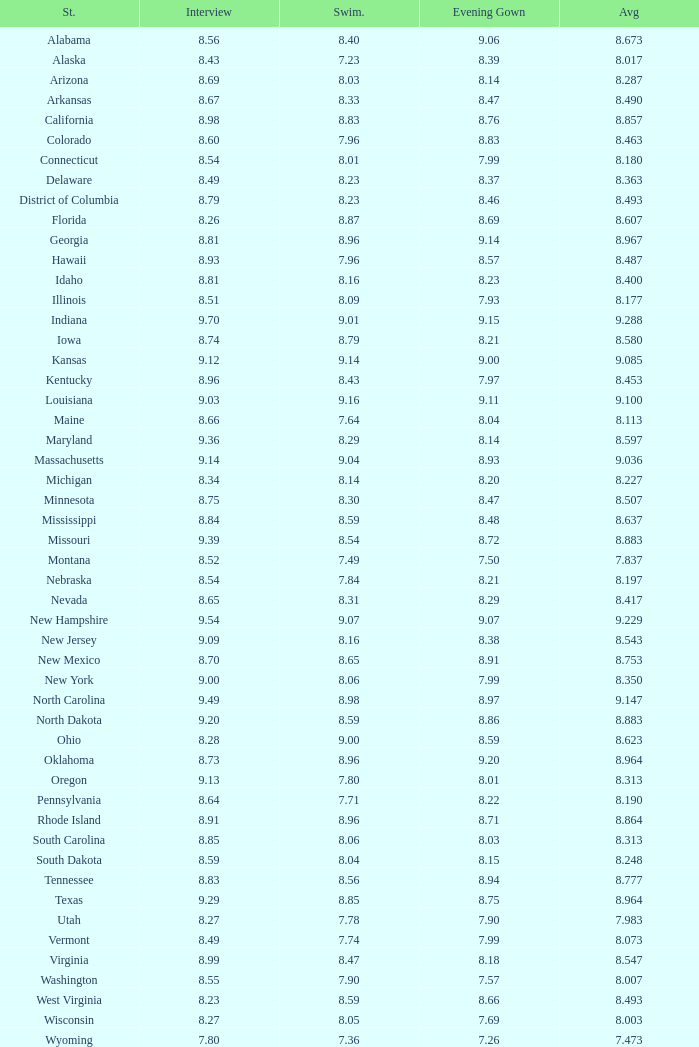Tell me the sum of interview for evening gown more than 8.37 and average of 8.363 None. Write the full table. {'header': ['St.', 'Interview', 'Swim.', 'Evening Gown', 'Avg'], 'rows': [['Alabama', '8.56', '8.40', '9.06', '8.673'], ['Alaska', '8.43', '7.23', '8.39', '8.017'], ['Arizona', '8.69', '8.03', '8.14', '8.287'], ['Arkansas', '8.67', '8.33', '8.47', '8.490'], ['California', '8.98', '8.83', '8.76', '8.857'], ['Colorado', '8.60', '7.96', '8.83', '8.463'], ['Connecticut', '8.54', '8.01', '7.99', '8.180'], ['Delaware', '8.49', '8.23', '8.37', '8.363'], ['District of Columbia', '8.79', '8.23', '8.46', '8.493'], ['Florida', '8.26', '8.87', '8.69', '8.607'], ['Georgia', '8.81', '8.96', '9.14', '8.967'], ['Hawaii', '8.93', '7.96', '8.57', '8.487'], ['Idaho', '8.81', '8.16', '8.23', '8.400'], ['Illinois', '8.51', '8.09', '7.93', '8.177'], ['Indiana', '9.70', '9.01', '9.15', '9.288'], ['Iowa', '8.74', '8.79', '8.21', '8.580'], ['Kansas', '9.12', '9.14', '9.00', '9.085'], ['Kentucky', '8.96', '8.43', '7.97', '8.453'], ['Louisiana', '9.03', '9.16', '9.11', '9.100'], ['Maine', '8.66', '7.64', '8.04', '8.113'], ['Maryland', '9.36', '8.29', '8.14', '8.597'], ['Massachusetts', '9.14', '9.04', '8.93', '9.036'], ['Michigan', '8.34', '8.14', '8.20', '8.227'], ['Minnesota', '8.75', '8.30', '8.47', '8.507'], ['Mississippi', '8.84', '8.59', '8.48', '8.637'], ['Missouri', '9.39', '8.54', '8.72', '8.883'], ['Montana', '8.52', '7.49', '7.50', '7.837'], ['Nebraska', '8.54', '7.84', '8.21', '8.197'], ['Nevada', '8.65', '8.31', '8.29', '8.417'], ['New Hampshire', '9.54', '9.07', '9.07', '9.229'], ['New Jersey', '9.09', '8.16', '8.38', '8.543'], ['New Mexico', '8.70', '8.65', '8.91', '8.753'], ['New York', '9.00', '8.06', '7.99', '8.350'], ['North Carolina', '9.49', '8.98', '8.97', '9.147'], ['North Dakota', '9.20', '8.59', '8.86', '8.883'], ['Ohio', '8.28', '9.00', '8.59', '8.623'], ['Oklahoma', '8.73', '8.96', '9.20', '8.964'], ['Oregon', '9.13', '7.80', '8.01', '8.313'], ['Pennsylvania', '8.64', '7.71', '8.22', '8.190'], ['Rhode Island', '8.91', '8.96', '8.71', '8.864'], ['South Carolina', '8.85', '8.06', '8.03', '8.313'], ['South Dakota', '8.59', '8.04', '8.15', '8.248'], ['Tennessee', '8.83', '8.56', '8.94', '8.777'], ['Texas', '9.29', '8.85', '8.75', '8.964'], ['Utah', '8.27', '7.78', '7.90', '7.983'], ['Vermont', '8.49', '7.74', '7.99', '8.073'], ['Virginia', '8.99', '8.47', '8.18', '8.547'], ['Washington', '8.55', '7.90', '7.57', '8.007'], ['West Virginia', '8.23', '8.59', '8.66', '8.493'], ['Wisconsin', '8.27', '8.05', '7.69', '8.003'], ['Wyoming', '7.80', '7.36', '7.26', '7.473']]} 